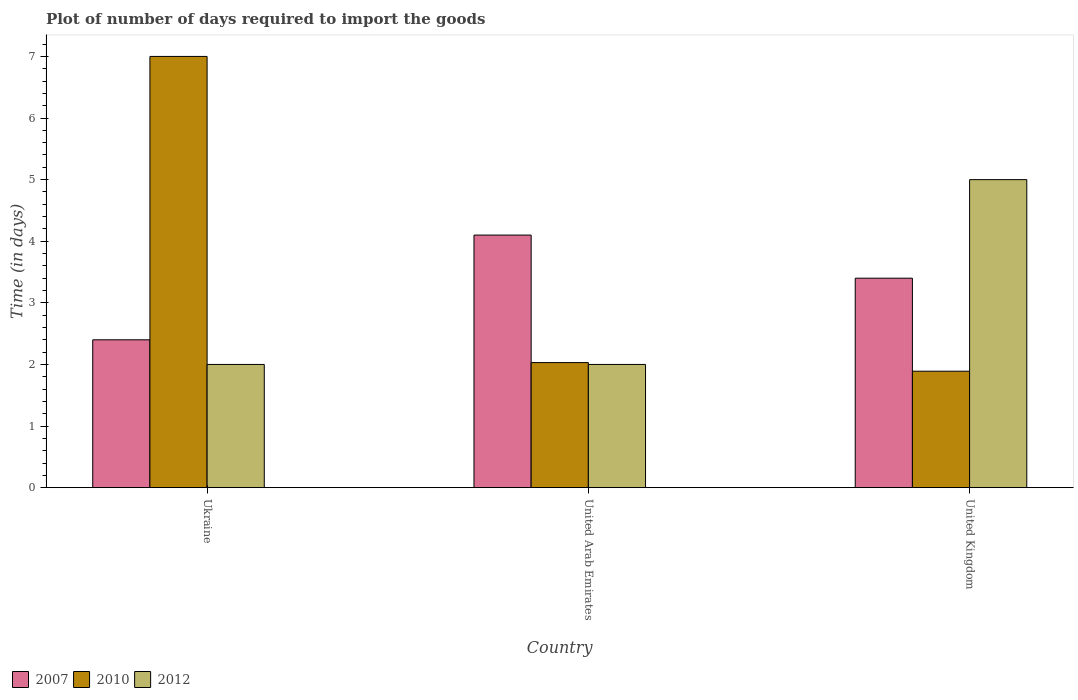How many different coloured bars are there?
Provide a succinct answer. 3. Are the number of bars on each tick of the X-axis equal?
Your response must be concise. Yes. How many bars are there on the 3rd tick from the right?
Make the answer very short. 3. What is the label of the 1st group of bars from the left?
Your answer should be compact. Ukraine. In how many cases, is the number of bars for a given country not equal to the number of legend labels?
Keep it short and to the point. 0. What is the time required to import goods in 2007 in United Kingdom?
Offer a terse response. 3.4. Across all countries, what is the minimum time required to import goods in 2012?
Give a very brief answer. 2. In which country was the time required to import goods in 2012 maximum?
Provide a short and direct response. United Kingdom. In which country was the time required to import goods in 2010 minimum?
Your answer should be very brief. United Kingdom. What is the difference between the time required to import goods in 2012 in Ukraine and that in United Arab Emirates?
Make the answer very short. 0. What is the difference between the time required to import goods in 2007 in Ukraine and the time required to import goods in 2010 in United Arab Emirates?
Offer a very short reply. 0.37. What is the average time required to import goods in 2010 per country?
Make the answer very short. 3.64. What is the difference between the time required to import goods of/in 2012 and time required to import goods of/in 2010 in United Kingdom?
Provide a short and direct response. 3.11. In how many countries, is the time required to import goods in 2007 greater than 4.6 days?
Provide a short and direct response. 0. What is the ratio of the time required to import goods in 2007 in Ukraine to that in United Kingdom?
Keep it short and to the point. 0.71. Is the time required to import goods in 2012 in Ukraine less than that in United Arab Emirates?
Ensure brevity in your answer.  No. Is the difference between the time required to import goods in 2012 in Ukraine and United Kingdom greater than the difference between the time required to import goods in 2010 in Ukraine and United Kingdom?
Provide a succinct answer. No. What is the difference between the highest and the second highest time required to import goods in 2012?
Offer a terse response. -3. In how many countries, is the time required to import goods in 2007 greater than the average time required to import goods in 2007 taken over all countries?
Your answer should be compact. 2. What does the 3rd bar from the left in Ukraine represents?
Provide a succinct answer. 2012. What does the 2nd bar from the right in United Arab Emirates represents?
Make the answer very short. 2010. Is it the case that in every country, the sum of the time required to import goods in 2007 and time required to import goods in 2012 is greater than the time required to import goods in 2010?
Ensure brevity in your answer.  No. How many bars are there?
Your response must be concise. 9. How many legend labels are there?
Make the answer very short. 3. How are the legend labels stacked?
Give a very brief answer. Horizontal. What is the title of the graph?
Your response must be concise. Plot of number of days required to import the goods. What is the label or title of the Y-axis?
Make the answer very short. Time (in days). What is the Time (in days) in 2007 in Ukraine?
Your answer should be compact. 2.4. What is the Time (in days) of 2010 in United Arab Emirates?
Provide a short and direct response. 2.03. What is the Time (in days) of 2007 in United Kingdom?
Ensure brevity in your answer.  3.4. What is the Time (in days) in 2010 in United Kingdom?
Ensure brevity in your answer.  1.89. What is the Time (in days) in 2012 in United Kingdom?
Your answer should be compact. 5. Across all countries, what is the minimum Time (in days) of 2007?
Your answer should be very brief. 2.4. Across all countries, what is the minimum Time (in days) of 2010?
Ensure brevity in your answer.  1.89. Across all countries, what is the minimum Time (in days) in 2012?
Provide a short and direct response. 2. What is the total Time (in days) in 2007 in the graph?
Provide a succinct answer. 9.9. What is the total Time (in days) in 2010 in the graph?
Your answer should be compact. 10.92. What is the total Time (in days) of 2012 in the graph?
Offer a very short reply. 9. What is the difference between the Time (in days) in 2010 in Ukraine and that in United Arab Emirates?
Keep it short and to the point. 4.97. What is the difference between the Time (in days) of 2012 in Ukraine and that in United Arab Emirates?
Offer a very short reply. 0. What is the difference between the Time (in days) in 2010 in Ukraine and that in United Kingdom?
Offer a terse response. 5.11. What is the difference between the Time (in days) of 2010 in United Arab Emirates and that in United Kingdom?
Keep it short and to the point. 0.14. What is the difference between the Time (in days) in 2012 in United Arab Emirates and that in United Kingdom?
Your answer should be very brief. -3. What is the difference between the Time (in days) in 2007 in Ukraine and the Time (in days) in 2010 in United Arab Emirates?
Keep it short and to the point. 0.37. What is the difference between the Time (in days) in 2007 in Ukraine and the Time (in days) in 2010 in United Kingdom?
Offer a very short reply. 0.51. What is the difference between the Time (in days) of 2007 in Ukraine and the Time (in days) of 2012 in United Kingdom?
Offer a terse response. -2.6. What is the difference between the Time (in days) of 2010 in Ukraine and the Time (in days) of 2012 in United Kingdom?
Provide a short and direct response. 2. What is the difference between the Time (in days) of 2007 in United Arab Emirates and the Time (in days) of 2010 in United Kingdom?
Your answer should be very brief. 2.21. What is the difference between the Time (in days) of 2010 in United Arab Emirates and the Time (in days) of 2012 in United Kingdom?
Offer a very short reply. -2.97. What is the average Time (in days) in 2007 per country?
Keep it short and to the point. 3.3. What is the average Time (in days) in 2010 per country?
Your answer should be very brief. 3.64. What is the difference between the Time (in days) of 2007 and Time (in days) of 2010 in United Arab Emirates?
Your answer should be very brief. 2.07. What is the difference between the Time (in days) in 2010 and Time (in days) in 2012 in United Arab Emirates?
Ensure brevity in your answer.  0.03. What is the difference between the Time (in days) in 2007 and Time (in days) in 2010 in United Kingdom?
Make the answer very short. 1.51. What is the difference between the Time (in days) in 2007 and Time (in days) in 2012 in United Kingdom?
Ensure brevity in your answer.  -1.6. What is the difference between the Time (in days) in 2010 and Time (in days) in 2012 in United Kingdom?
Ensure brevity in your answer.  -3.11. What is the ratio of the Time (in days) of 2007 in Ukraine to that in United Arab Emirates?
Keep it short and to the point. 0.59. What is the ratio of the Time (in days) of 2010 in Ukraine to that in United Arab Emirates?
Offer a terse response. 3.45. What is the ratio of the Time (in days) of 2007 in Ukraine to that in United Kingdom?
Keep it short and to the point. 0.71. What is the ratio of the Time (in days) in 2010 in Ukraine to that in United Kingdom?
Your answer should be very brief. 3.7. What is the ratio of the Time (in days) of 2007 in United Arab Emirates to that in United Kingdom?
Your answer should be compact. 1.21. What is the ratio of the Time (in days) in 2010 in United Arab Emirates to that in United Kingdom?
Make the answer very short. 1.07. What is the ratio of the Time (in days) in 2012 in United Arab Emirates to that in United Kingdom?
Ensure brevity in your answer.  0.4. What is the difference between the highest and the second highest Time (in days) of 2010?
Offer a very short reply. 4.97. What is the difference between the highest and the second highest Time (in days) of 2012?
Your answer should be very brief. 3. What is the difference between the highest and the lowest Time (in days) of 2010?
Give a very brief answer. 5.11. What is the difference between the highest and the lowest Time (in days) in 2012?
Make the answer very short. 3. 